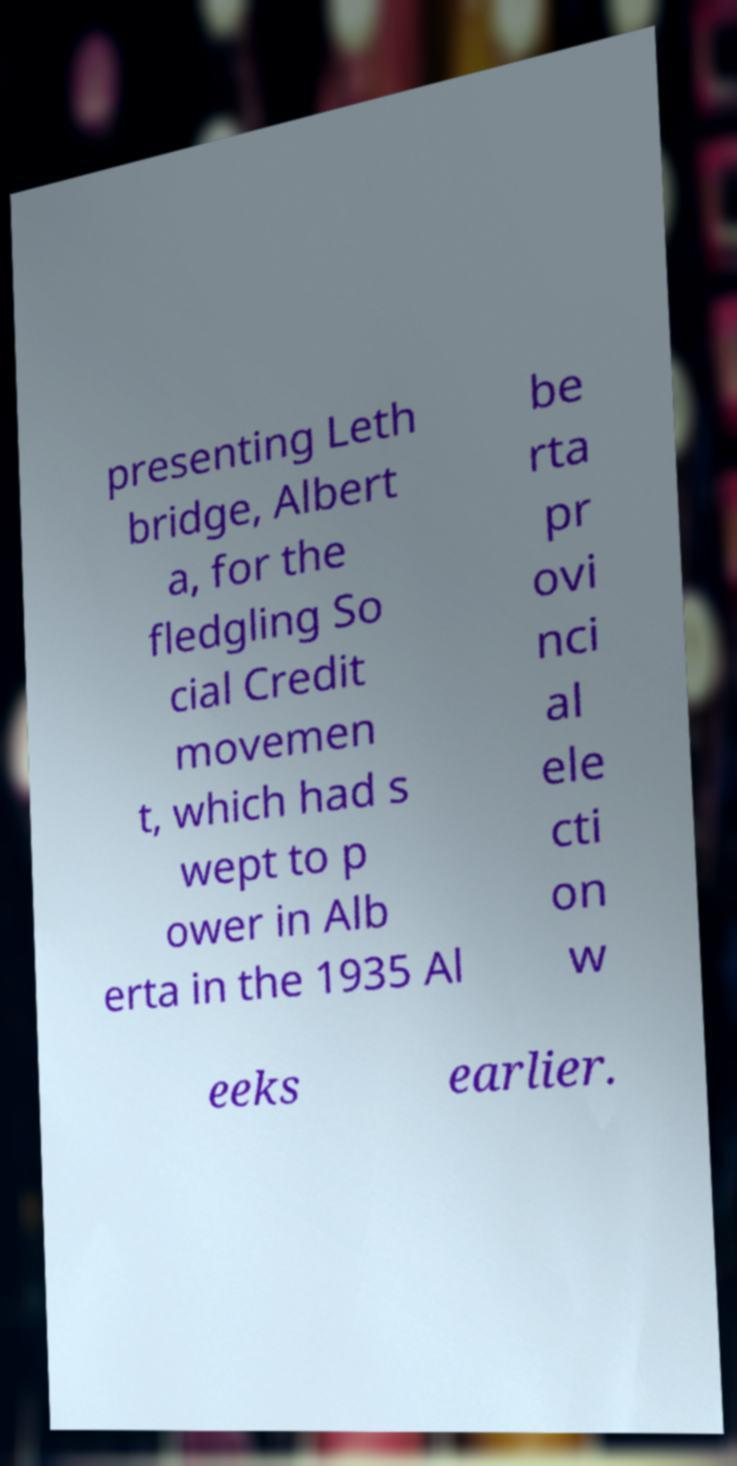I need the written content from this picture converted into text. Can you do that? presenting Leth bridge, Albert a, for the fledgling So cial Credit movemen t, which had s wept to p ower in Alb erta in the 1935 Al be rta pr ovi nci al ele cti on w eeks earlier. 